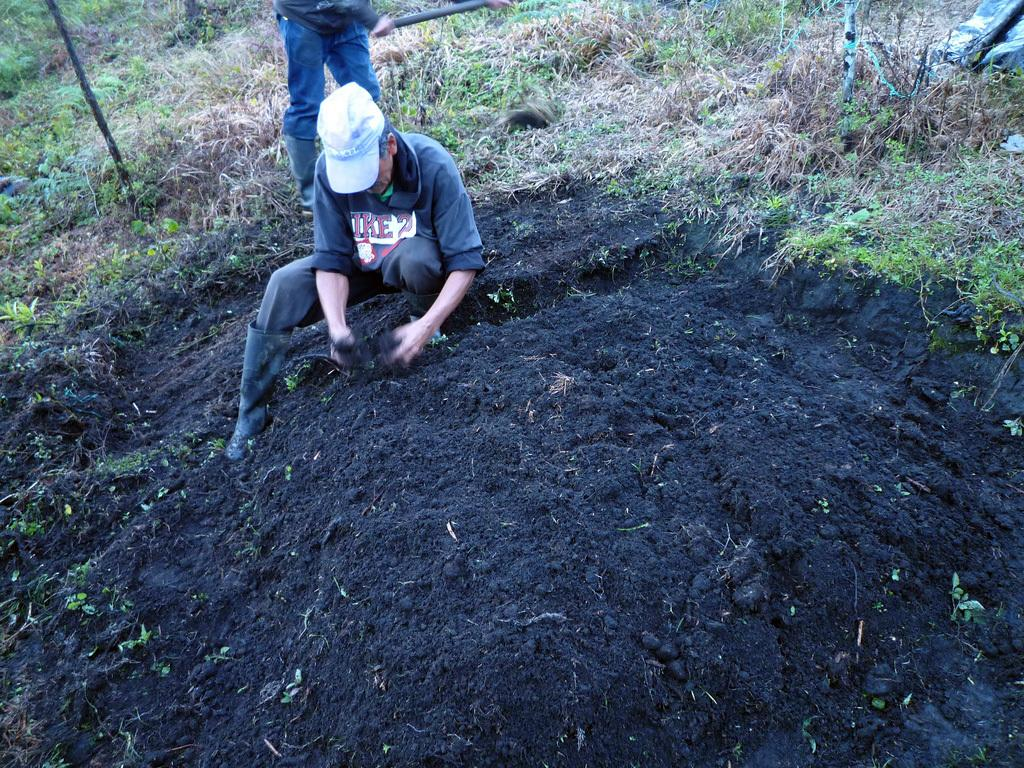How many people are present in the image? There are two men in the image. What is one of the men doing in the image? One man is digging the soil. What is the other man doing in the image? The other man is standing behind him. What type of vegetation can be seen in the background of the image? There is grass in the background of the image. What type of meat is being grilled in the image? There is no meat or grill present in the image; it features two men, one of whom is digging the soil. How many tents are visible in the image? There are no tents present in the image. 